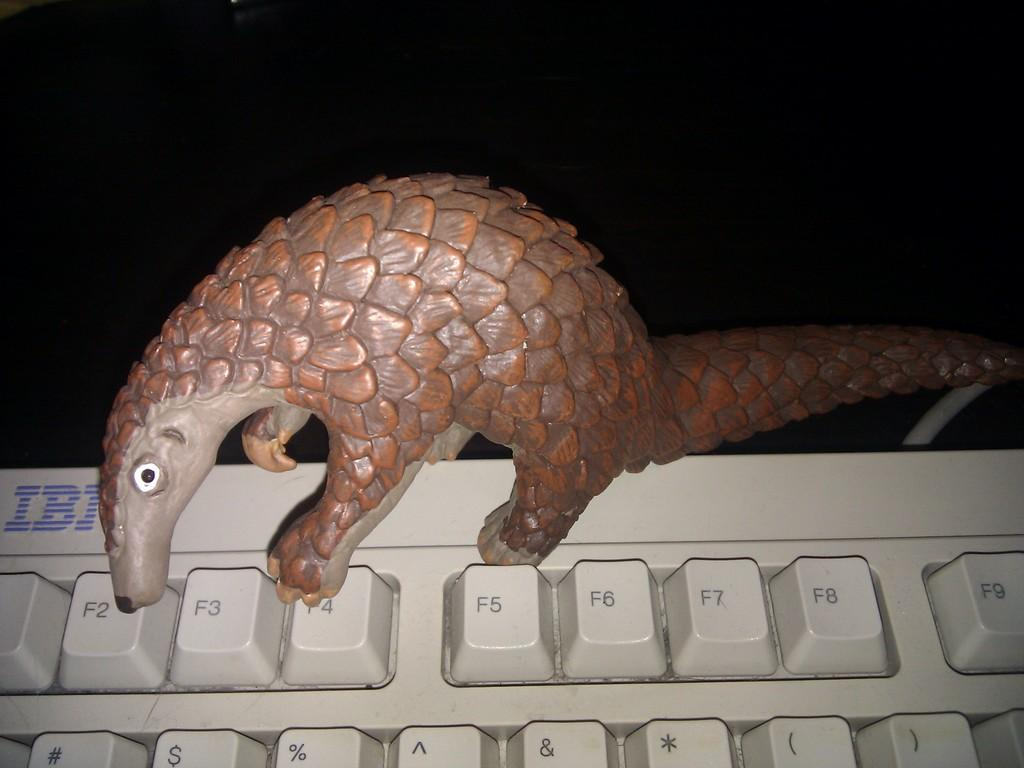What type of object is present on the keyboard in the image? There is a toy animal on the keyboard in the image. What is the color of the toy animal? The toy animal is brown in color. What can be seen in the background of the image? The background of the image is dark. How many quartz crystals are present on the back of the toy animal in the image? There are no quartz crystals present on the toy animal in the image, as it is a brown toy animal on a keyboard. 